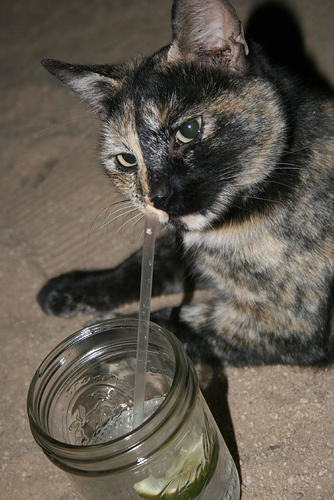Describe the objects in this image and their specific colors. I can see cat in black, gray, and darkgray tones and cup in black and gray tones in this image. 